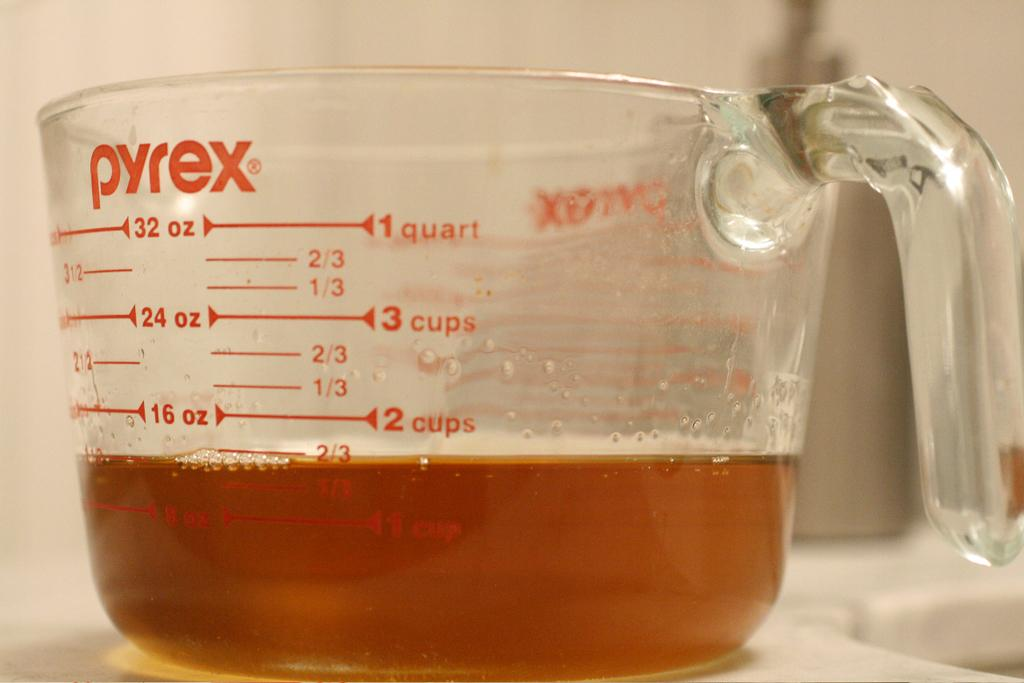<image>
Present a compact description of the photo's key features. A glass mixing container has a maximum measurement of 32 ounces and a minimum of 8. 